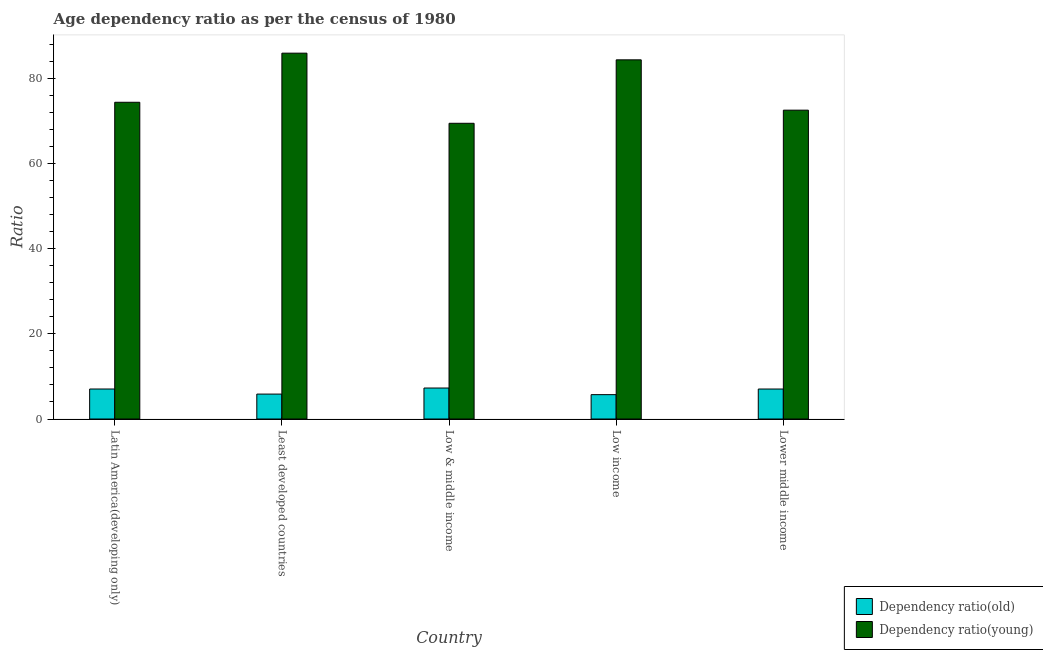Are the number of bars per tick equal to the number of legend labels?
Offer a terse response. Yes. What is the label of the 1st group of bars from the left?
Provide a short and direct response. Latin America(developing only). What is the age dependency ratio(old) in Low income?
Your answer should be very brief. 5.72. Across all countries, what is the maximum age dependency ratio(young)?
Provide a short and direct response. 85.89. Across all countries, what is the minimum age dependency ratio(old)?
Ensure brevity in your answer.  5.72. In which country was the age dependency ratio(young) maximum?
Keep it short and to the point. Least developed countries. In which country was the age dependency ratio(old) minimum?
Make the answer very short. Low income. What is the total age dependency ratio(old) in the graph?
Offer a very short reply. 32.93. What is the difference between the age dependency ratio(young) in Least developed countries and that in Low & middle income?
Provide a short and direct response. 16.46. What is the difference between the age dependency ratio(old) in Lower middle income and the age dependency ratio(young) in Least developed countries?
Provide a succinct answer. -78.85. What is the average age dependency ratio(young) per country?
Your answer should be compact. 77.31. What is the difference between the age dependency ratio(old) and age dependency ratio(young) in Least developed countries?
Your answer should be very brief. -80.04. In how many countries, is the age dependency ratio(old) greater than 52 ?
Offer a very short reply. 0. What is the ratio of the age dependency ratio(old) in Low & middle income to that in Low income?
Offer a very short reply. 1.27. What is the difference between the highest and the second highest age dependency ratio(old)?
Offer a very short reply. 0.23. What is the difference between the highest and the lowest age dependency ratio(young)?
Keep it short and to the point. 16.46. Is the sum of the age dependency ratio(old) in Latin America(developing only) and Low income greater than the maximum age dependency ratio(young) across all countries?
Give a very brief answer. No. What does the 1st bar from the left in Latin America(developing only) represents?
Keep it short and to the point. Dependency ratio(old). What does the 2nd bar from the right in Low & middle income represents?
Give a very brief answer. Dependency ratio(old). Does the graph contain grids?
Keep it short and to the point. No. Where does the legend appear in the graph?
Offer a terse response. Bottom right. What is the title of the graph?
Your answer should be compact. Age dependency ratio as per the census of 1980. What is the label or title of the Y-axis?
Your answer should be compact. Ratio. What is the Ratio in Dependency ratio(old) in Latin America(developing only)?
Ensure brevity in your answer.  7.04. What is the Ratio of Dependency ratio(young) in Latin America(developing only)?
Your answer should be very brief. 74.36. What is the Ratio of Dependency ratio(old) in Least developed countries?
Ensure brevity in your answer.  5.85. What is the Ratio of Dependency ratio(young) in Least developed countries?
Provide a short and direct response. 85.89. What is the Ratio of Dependency ratio(old) in Low & middle income?
Your answer should be compact. 7.28. What is the Ratio of Dependency ratio(young) in Low & middle income?
Make the answer very short. 69.43. What is the Ratio in Dependency ratio(old) in Low income?
Provide a succinct answer. 5.72. What is the Ratio of Dependency ratio(young) in Low income?
Your response must be concise. 84.33. What is the Ratio in Dependency ratio(old) in Lower middle income?
Keep it short and to the point. 7.04. What is the Ratio in Dependency ratio(young) in Lower middle income?
Offer a very short reply. 72.51. Across all countries, what is the maximum Ratio in Dependency ratio(old)?
Your response must be concise. 7.28. Across all countries, what is the maximum Ratio in Dependency ratio(young)?
Give a very brief answer. 85.89. Across all countries, what is the minimum Ratio in Dependency ratio(old)?
Provide a short and direct response. 5.72. Across all countries, what is the minimum Ratio in Dependency ratio(young)?
Give a very brief answer. 69.43. What is the total Ratio in Dependency ratio(old) in the graph?
Give a very brief answer. 32.93. What is the total Ratio of Dependency ratio(young) in the graph?
Keep it short and to the point. 386.53. What is the difference between the Ratio in Dependency ratio(old) in Latin America(developing only) and that in Least developed countries?
Your response must be concise. 1.19. What is the difference between the Ratio of Dependency ratio(young) in Latin America(developing only) and that in Least developed countries?
Offer a terse response. -11.53. What is the difference between the Ratio in Dependency ratio(old) in Latin America(developing only) and that in Low & middle income?
Provide a short and direct response. -0.23. What is the difference between the Ratio in Dependency ratio(young) in Latin America(developing only) and that in Low & middle income?
Provide a succinct answer. 4.94. What is the difference between the Ratio in Dependency ratio(old) in Latin America(developing only) and that in Low income?
Keep it short and to the point. 1.32. What is the difference between the Ratio of Dependency ratio(young) in Latin America(developing only) and that in Low income?
Offer a terse response. -9.96. What is the difference between the Ratio of Dependency ratio(old) in Latin America(developing only) and that in Lower middle income?
Provide a succinct answer. 0. What is the difference between the Ratio of Dependency ratio(young) in Latin America(developing only) and that in Lower middle income?
Ensure brevity in your answer.  1.85. What is the difference between the Ratio of Dependency ratio(old) in Least developed countries and that in Low & middle income?
Make the answer very short. -1.42. What is the difference between the Ratio of Dependency ratio(young) in Least developed countries and that in Low & middle income?
Keep it short and to the point. 16.46. What is the difference between the Ratio of Dependency ratio(old) in Least developed countries and that in Low income?
Give a very brief answer. 0.13. What is the difference between the Ratio of Dependency ratio(young) in Least developed countries and that in Low income?
Keep it short and to the point. 1.57. What is the difference between the Ratio of Dependency ratio(old) in Least developed countries and that in Lower middle income?
Keep it short and to the point. -1.19. What is the difference between the Ratio of Dependency ratio(young) in Least developed countries and that in Lower middle income?
Your answer should be compact. 13.38. What is the difference between the Ratio of Dependency ratio(old) in Low & middle income and that in Low income?
Ensure brevity in your answer.  1.56. What is the difference between the Ratio of Dependency ratio(young) in Low & middle income and that in Low income?
Offer a very short reply. -14.9. What is the difference between the Ratio of Dependency ratio(old) in Low & middle income and that in Lower middle income?
Offer a very short reply. 0.24. What is the difference between the Ratio of Dependency ratio(young) in Low & middle income and that in Lower middle income?
Your answer should be compact. -3.08. What is the difference between the Ratio of Dependency ratio(old) in Low income and that in Lower middle income?
Give a very brief answer. -1.32. What is the difference between the Ratio of Dependency ratio(young) in Low income and that in Lower middle income?
Keep it short and to the point. 11.81. What is the difference between the Ratio of Dependency ratio(old) in Latin America(developing only) and the Ratio of Dependency ratio(young) in Least developed countries?
Your response must be concise. -78.85. What is the difference between the Ratio in Dependency ratio(old) in Latin America(developing only) and the Ratio in Dependency ratio(young) in Low & middle income?
Your answer should be very brief. -62.38. What is the difference between the Ratio of Dependency ratio(old) in Latin America(developing only) and the Ratio of Dependency ratio(young) in Low income?
Your answer should be very brief. -77.28. What is the difference between the Ratio of Dependency ratio(old) in Latin America(developing only) and the Ratio of Dependency ratio(young) in Lower middle income?
Provide a short and direct response. -65.47. What is the difference between the Ratio of Dependency ratio(old) in Least developed countries and the Ratio of Dependency ratio(young) in Low & middle income?
Your answer should be very brief. -63.58. What is the difference between the Ratio in Dependency ratio(old) in Least developed countries and the Ratio in Dependency ratio(young) in Low income?
Your response must be concise. -78.48. What is the difference between the Ratio of Dependency ratio(old) in Least developed countries and the Ratio of Dependency ratio(young) in Lower middle income?
Your response must be concise. -66.66. What is the difference between the Ratio of Dependency ratio(old) in Low & middle income and the Ratio of Dependency ratio(young) in Low income?
Ensure brevity in your answer.  -77.05. What is the difference between the Ratio of Dependency ratio(old) in Low & middle income and the Ratio of Dependency ratio(young) in Lower middle income?
Offer a very short reply. -65.24. What is the difference between the Ratio of Dependency ratio(old) in Low income and the Ratio of Dependency ratio(young) in Lower middle income?
Ensure brevity in your answer.  -66.79. What is the average Ratio in Dependency ratio(old) per country?
Your answer should be very brief. 6.59. What is the average Ratio in Dependency ratio(young) per country?
Give a very brief answer. 77.31. What is the difference between the Ratio in Dependency ratio(old) and Ratio in Dependency ratio(young) in Latin America(developing only)?
Give a very brief answer. -67.32. What is the difference between the Ratio of Dependency ratio(old) and Ratio of Dependency ratio(young) in Least developed countries?
Make the answer very short. -80.04. What is the difference between the Ratio of Dependency ratio(old) and Ratio of Dependency ratio(young) in Low & middle income?
Give a very brief answer. -62.15. What is the difference between the Ratio of Dependency ratio(old) and Ratio of Dependency ratio(young) in Low income?
Offer a very short reply. -78.61. What is the difference between the Ratio of Dependency ratio(old) and Ratio of Dependency ratio(young) in Lower middle income?
Your answer should be compact. -65.47. What is the ratio of the Ratio in Dependency ratio(old) in Latin America(developing only) to that in Least developed countries?
Your answer should be compact. 1.2. What is the ratio of the Ratio in Dependency ratio(young) in Latin America(developing only) to that in Least developed countries?
Your response must be concise. 0.87. What is the ratio of the Ratio in Dependency ratio(young) in Latin America(developing only) to that in Low & middle income?
Your answer should be compact. 1.07. What is the ratio of the Ratio of Dependency ratio(old) in Latin America(developing only) to that in Low income?
Provide a short and direct response. 1.23. What is the ratio of the Ratio of Dependency ratio(young) in Latin America(developing only) to that in Low income?
Give a very brief answer. 0.88. What is the ratio of the Ratio of Dependency ratio(old) in Latin America(developing only) to that in Lower middle income?
Your response must be concise. 1. What is the ratio of the Ratio of Dependency ratio(young) in Latin America(developing only) to that in Lower middle income?
Make the answer very short. 1.03. What is the ratio of the Ratio of Dependency ratio(old) in Least developed countries to that in Low & middle income?
Your response must be concise. 0.8. What is the ratio of the Ratio of Dependency ratio(young) in Least developed countries to that in Low & middle income?
Keep it short and to the point. 1.24. What is the ratio of the Ratio of Dependency ratio(old) in Least developed countries to that in Low income?
Your answer should be very brief. 1.02. What is the ratio of the Ratio of Dependency ratio(young) in Least developed countries to that in Low income?
Offer a very short reply. 1.02. What is the ratio of the Ratio of Dependency ratio(old) in Least developed countries to that in Lower middle income?
Provide a short and direct response. 0.83. What is the ratio of the Ratio of Dependency ratio(young) in Least developed countries to that in Lower middle income?
Ensure brevity in your answer.  1.18. What is the ratio of the Ratio of Dependency ratio(old) in Low & middle income to that in Low income?
Make the answer very short. 1.27. What is the ratio of the Ratio of Dependency ratio(young) in Low & middle income to that in Low income?
Your answer should be compact. 0.82. What is the ratio of the Ratio of Dependency ratio(old) in Low & middle income to that in Lower middle income?
Give a very brief answer. 1.03. What is the ratio of the Ratio in Dependency ratio(young) in Low & middle income to that in Lower middle income?
Your answer should be compact. 0.96. What is the ratio of the Ratio of Dependency ratio(old) in Low income to that in Lower middle income?
Provide a succinct answer. 0.81. What is the ratio of the Ratio in Dependency ratio(young) in Low income to that in Lower middle income?
Your answer should be compact. 1.16. What is the difference between the highest and the second highest Ratio in Dependency ratio(old)?
Provide a succinct answer. 0.23. What is the difference between the highest and the second highest Ratio in Dependency ratio(young)?
Your answer should be compact. 1.57. What is the difference between the highest and the lowest Ratio in Dependency ratio(old)?
Keep it short and to the point. 1.56. What is the difference between the highest and the lowest Ratio of Dependency ratio(young)?
Give a very brief answer. 16.46. 